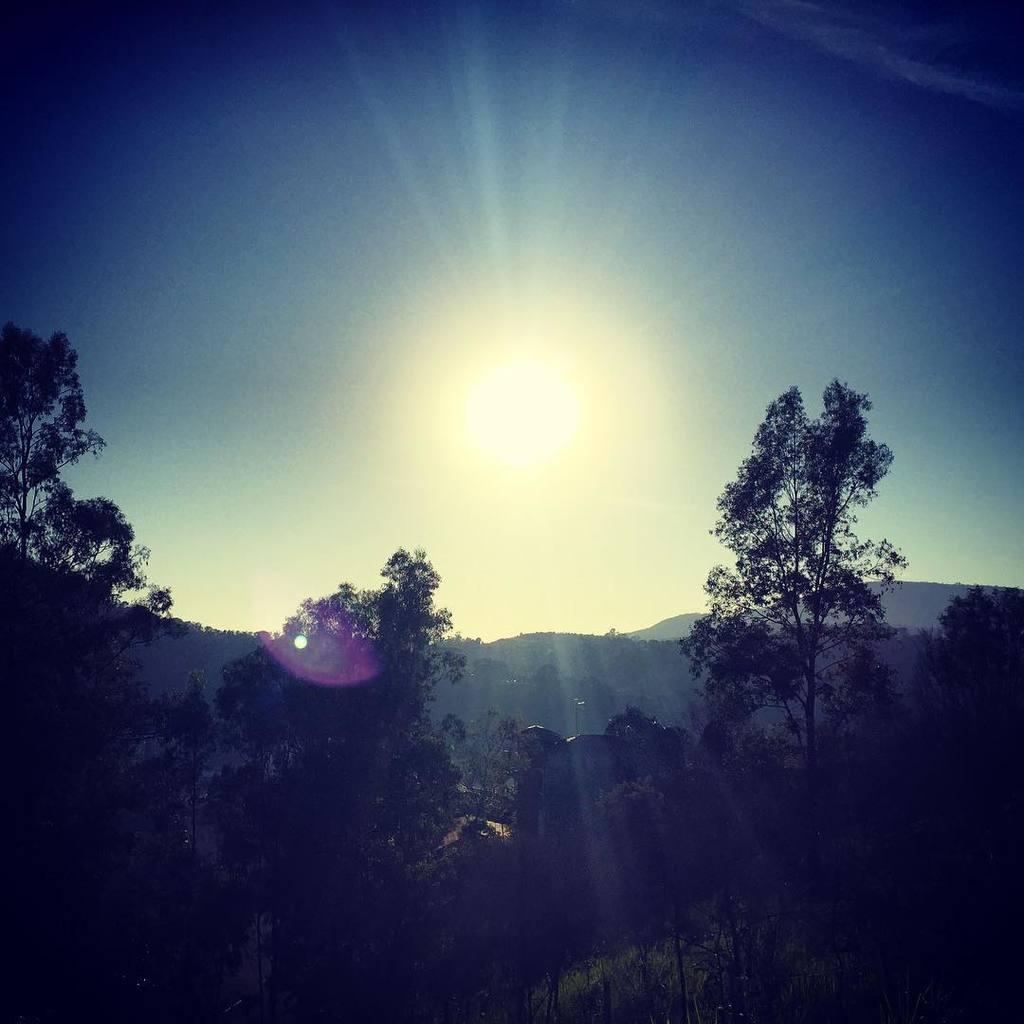What type of vegetation can be seen in the image? There are trees in the image, from left to right. What can be seen in the distance behind the trees? There are hills visible in the background of the image. What color is the sky in the image? The sky is blue in color. Can you see any birds flying over the ocean in the image? There is no ocean or birds visible in the image; it features trees, hills, and a blue sky. 